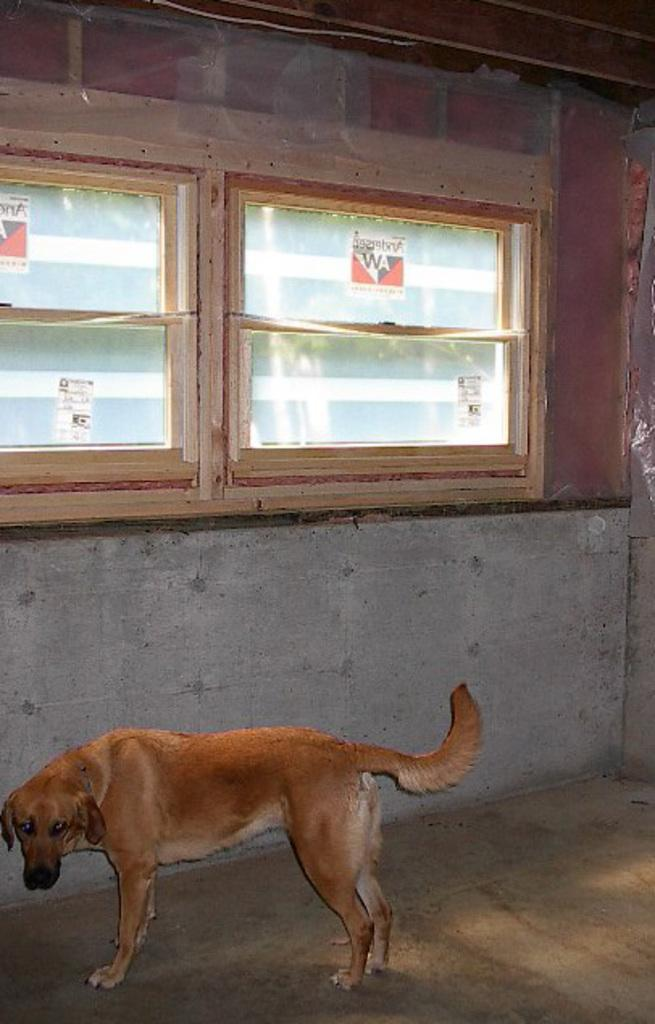What type of animal is in the image? There is a dog in the image. Where is the dog positioned in relation to the wall? The dog is in front of a wall. What architectural feature can be seen in the middle of the image? There is a window in the middle of the image. Can you tell me what time the dog is watching on the watch in the image? There is no watch present in the image, so it is not possible to determine the time the dog might be watching. 